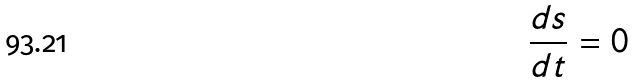Convert formula to latex. <formula><loc_0><loc_0><loc_500><loc_500>\frac { d s } { d t } = 0</formula> 